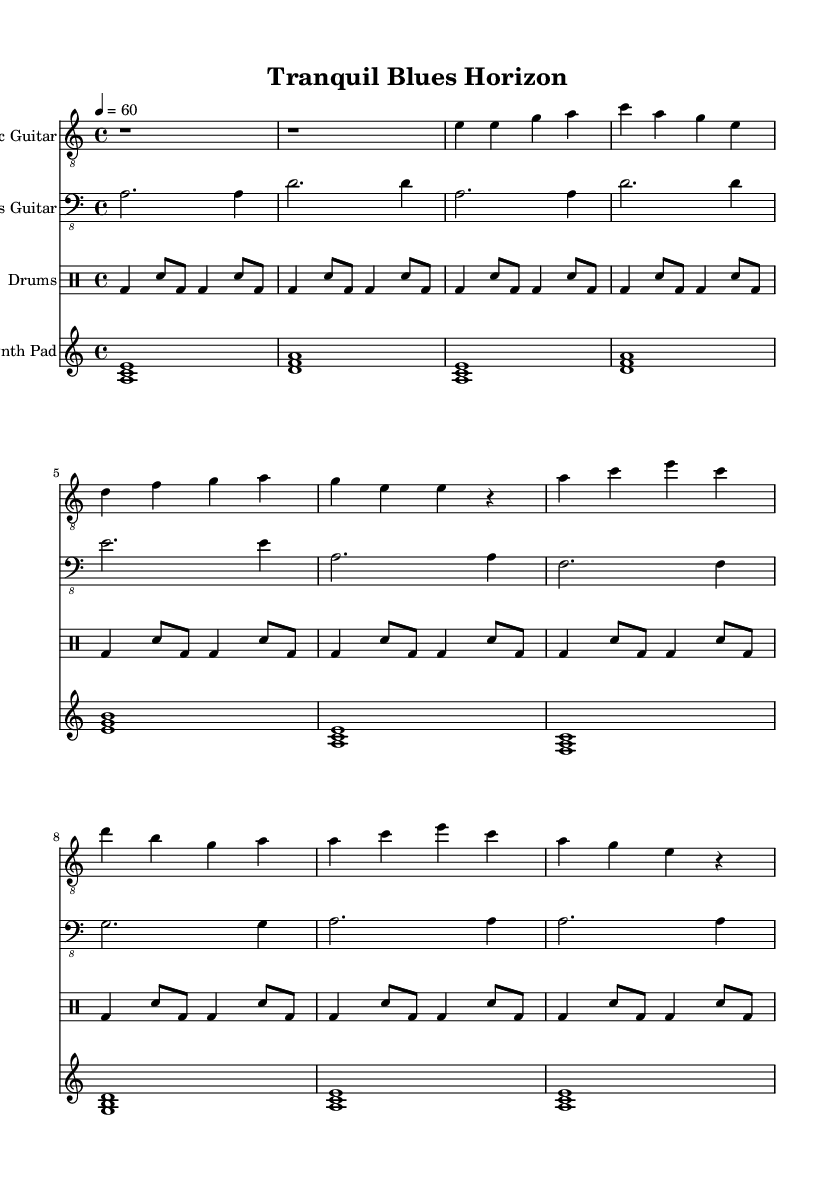What is the key signature of this music? The key signature is indicated at the beginning of the sheet music. It shows one flat (B♭) which corresponds to the key of A minor.
Answer: A minor What is the time signature of this music? The time signature is shown at the beginning of the score, specifying how many beats are in each measure. Here, it is 4/4, indicating four beats per measure.
Answer: 4/4 What is the tempo marking in this music? The tempo marking is displayed in beats per minute (BPM) and is set at 60, which means one beat lasts one second.
Answer: 60 How many measures are in the chorus section? By counting the measures of the chorus section indicated in the sheet music, there are four measures present.
Answer: 4 What instruments are used in this piece? The instruments are listed at the beginning of each staff in the score. There are four instruments: Electric Guitar, Bass Guitar, Drums, and Synth Pad.
Answer: Electric Guitar, Bass Guitar, Drums, Synth Pad What is the predominant genre of this music? The genre is defined by the style and elements present in the music. This piece is categorized as Electric Blues, incorporating ambient textures for relaxation.
Answer: Electric Blues How does the incorporation of synth pad enhance this piece? The synth pad adds ambient elements, creating a soothing backdrop that complements the electric blues style, which often features a grittier sound.
Answer: Enhances relaxation 